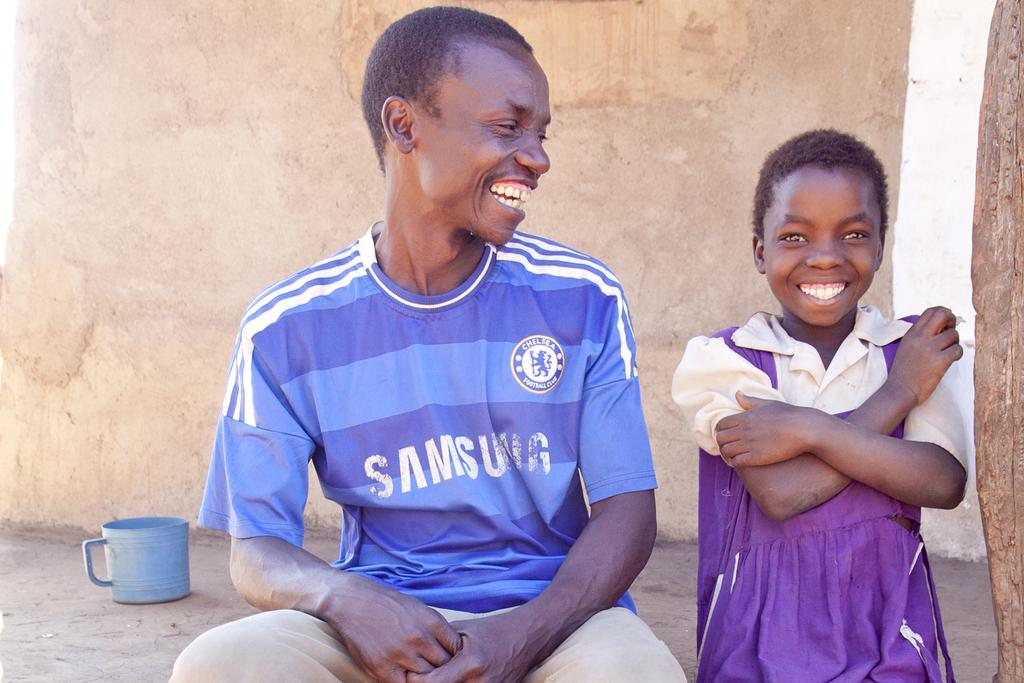How many people are in the image? There are two persons in the image. What are the persons doing in the image? The persons are sitting and smiling. What can be seen on the left side of the image? There is a cup on the left side of the image. What is visible in the background of the image? There is a wall in the background of the image. What type of reward is the person on the right holding in the image? There is no reward visible in the image; the persons are simply sitting and smiling. Can you tell me how many astronauts are present in the image? There are no astronauts or any reference to space in the image. 